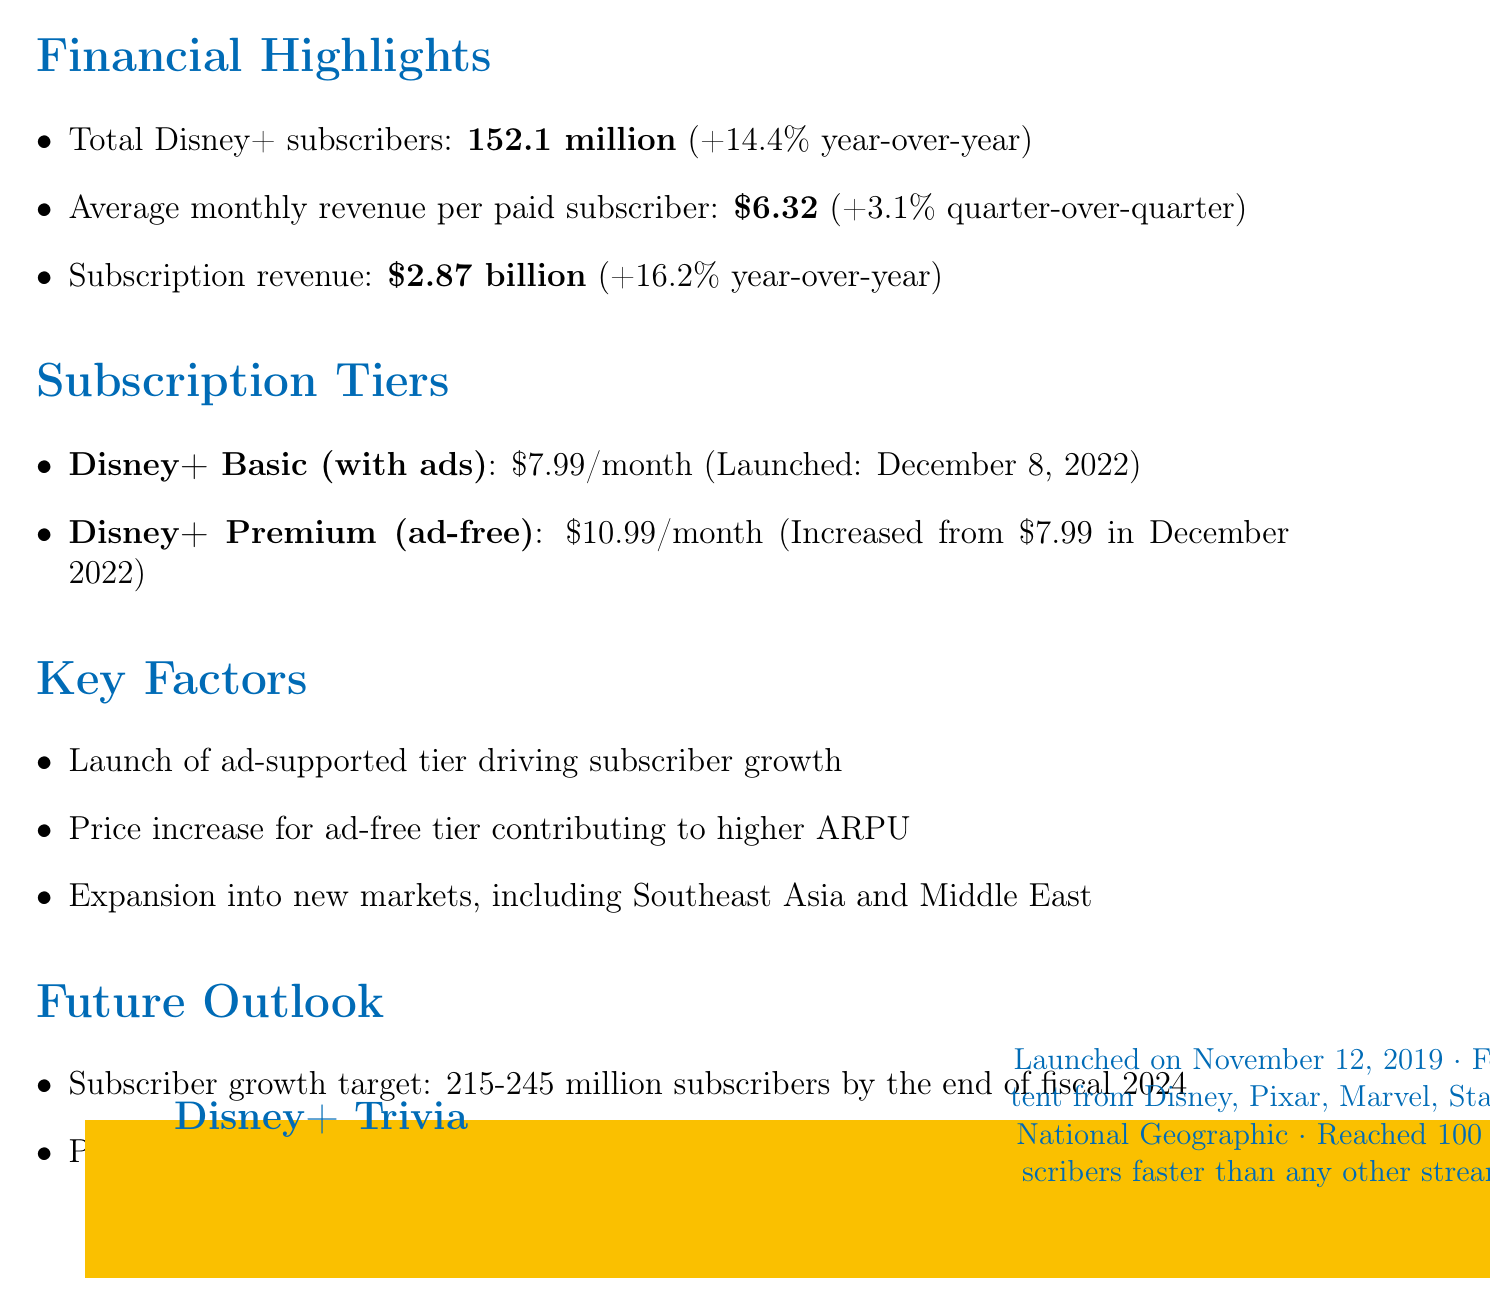What is the total number of Disney+ subscribers? The report states that the total number of subscribers is 152.1 million.
Answer: 152.1 million What is the average monthly revenue per paid subscriber? The average monthly revenue per paid subscriber is provided as $6.32.
Answer: $6.32 When was Disney+ Basic (with ads) launched? The document provides the launch date for Disney+ Basic (with ads) as December 8, 2022.
Answer: December 8, 2022 What is the subscription revenue for Disney+ in Q3 2023? The subscription revenue is mentioned as $2.87 billion in the report.
Answer: $2.87 billion What is the target for subscriber growth by the end of fiscal 2024? The growth target is stated to be between 215 and 245 million subscribers.
Answer: 215-245 million What contributed to the higher average revenue per user (ARPU)? The increase in price for the ad-free tier contributed to higher ARPU.
Answer: Price increase for ad-free tier Which regions is Disney+ expanding into? The report mentions expansion into Southeast Asia and the Middle East.
Answer: Southeast Asia and Middle East In what year was Disney+ launched? The document states that Disney+ was launched on November 12, 2019.
Answer: 2019 What is the profitability goal for Disney+ operations? The goal is to achieve profitability in Disney+ operations by fiscal 2024.
Answer: Fiscal 2024 